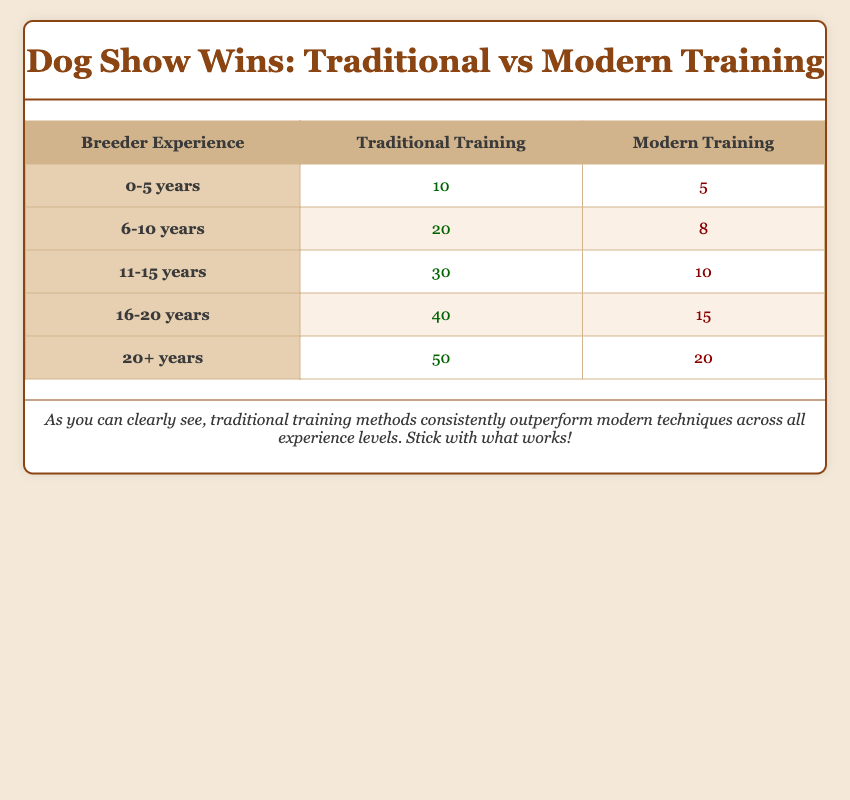What is the total number of show wins for breeders with 11-15 years of experience using traditional training? The table shows that for breeders with 11-15 years of experience using traditional training, there were 30 show wins.
Answer: 30 What is the difference in show wins between breeders with 0-5 years of experience using traditional training and those using modern training? Breeders with 0-5 years of experience using traditional training won 10 shows, while those using modern training won 5 shows. The difference is 10 - 5 = 5 show wins.
Answer: 5 How many show wins did breeders with 16-20 years of experience achieve using modern training? The table states that for breeders with 16-20 years of experience using modern training, there were 15 show wins.
Answer: 15 Is the total number of show wins for traditional training more than the total for modern training across all experience levels? To find this, we add the traditional show wins: 10 + 20 + 30 + 40 + 50 = 150, and modern show wins: 5 + 8 + 10 + 15 + 20 = 58. Since 150 is greater than 58, the answer is yes.
Answer: Yes What is the average number of show wins for breeders using modern training across all experience levels? First, sum the modern show wins: 5 + 8 + 10 + 15 + 20 = 68. Then divide by the number of experience levels, which is 5. So, the average is 68 / 5 = 13.6.
Answer: 13.6 Which training style had more show wins for breeders with 20+ years of experience? According to the table, breeders with 20+ years of experience using traditional training won 50 shows, while those using modern training won 20 shows. Traditional training had more wins.
Answer: Traditional training If you combine show wins for traditional training from both 11-15 years and 16-20 years experience, what is the total? From the table, traditional training wins for 11-15 years is 30 and for 16-20 years is 40. The total is 30 + 40 = 70.
Answer: 70 Is it true that breeders with more than 15 years of experience had more wins with traditional training than those with less experience? For traditional training, breeders with 16-20 years had 40 wins and those with 20+ years had 50 wins, totaling 90. The lower experience categories (0-5 and 6-10 years combined traditional wins) are 10 + 20 = 30. Since 90 is greater than 30, the statement is true.
Answer: Yes What are the show wins for breeders with 6-10 years of experience using both training styles combined? For breeders with 6-10 years, traditional training won 20 shows and modern training won 8 shows. The combined total is 20 + 8 = 28.
Answer: 28 